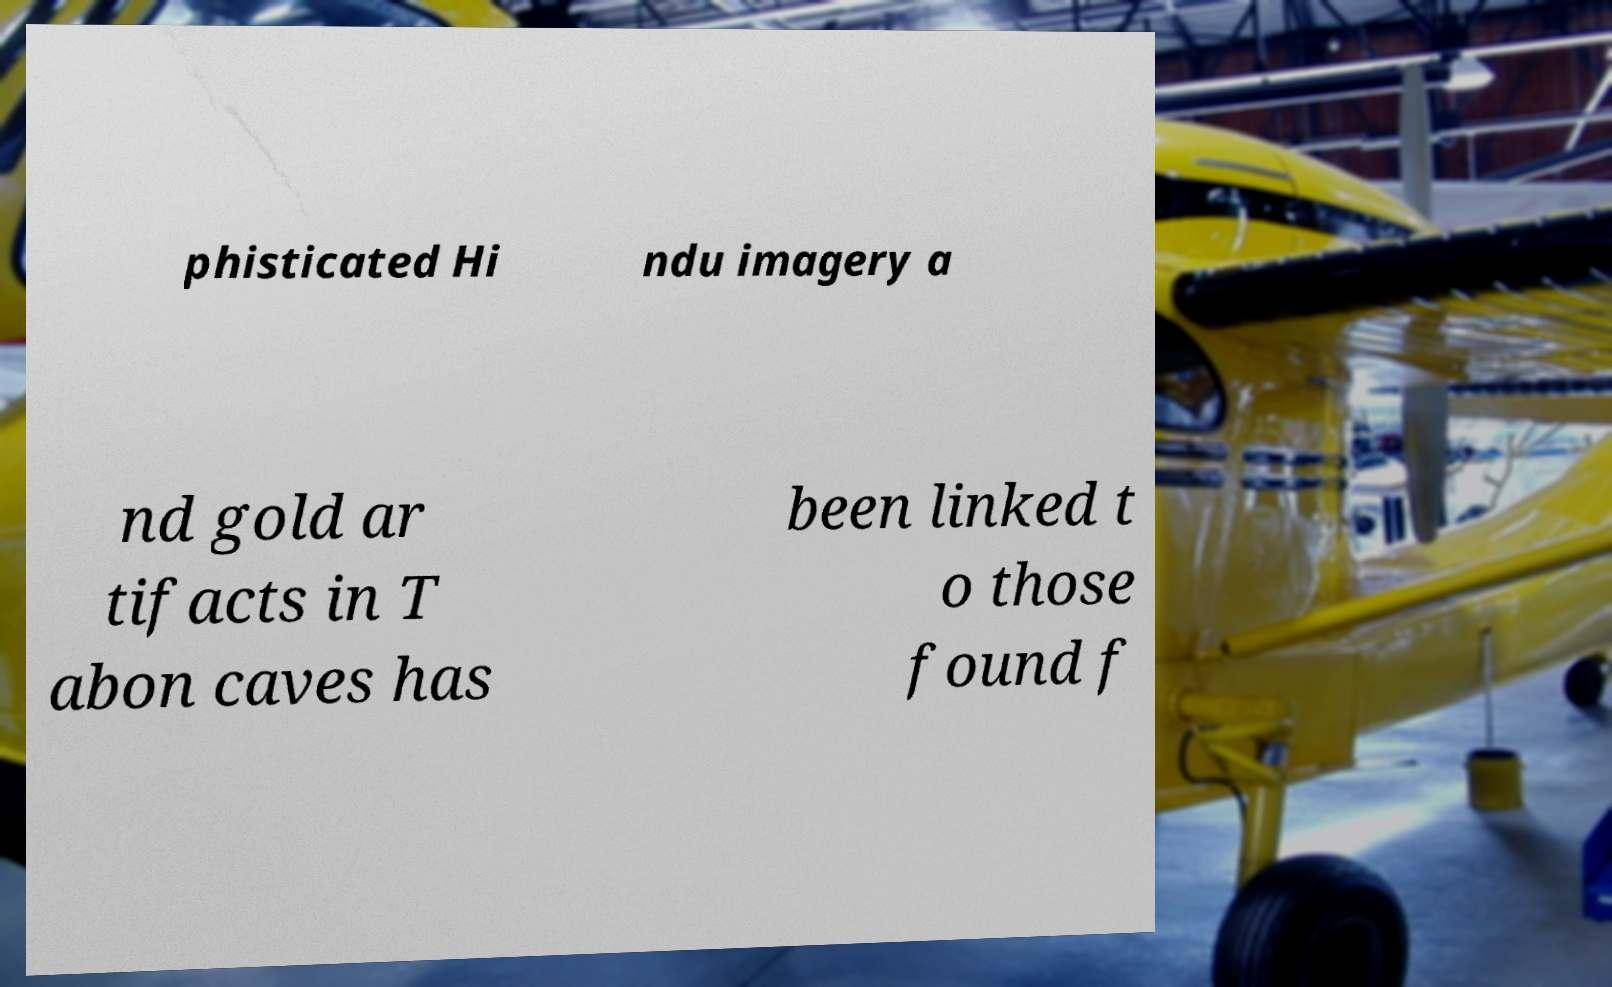What messages or text are displayed in this image? I need them in a readable, typed format. phisticated Hi ndu imagery a nd gold ar tifacts in T abon caves has been linked t o those found f 